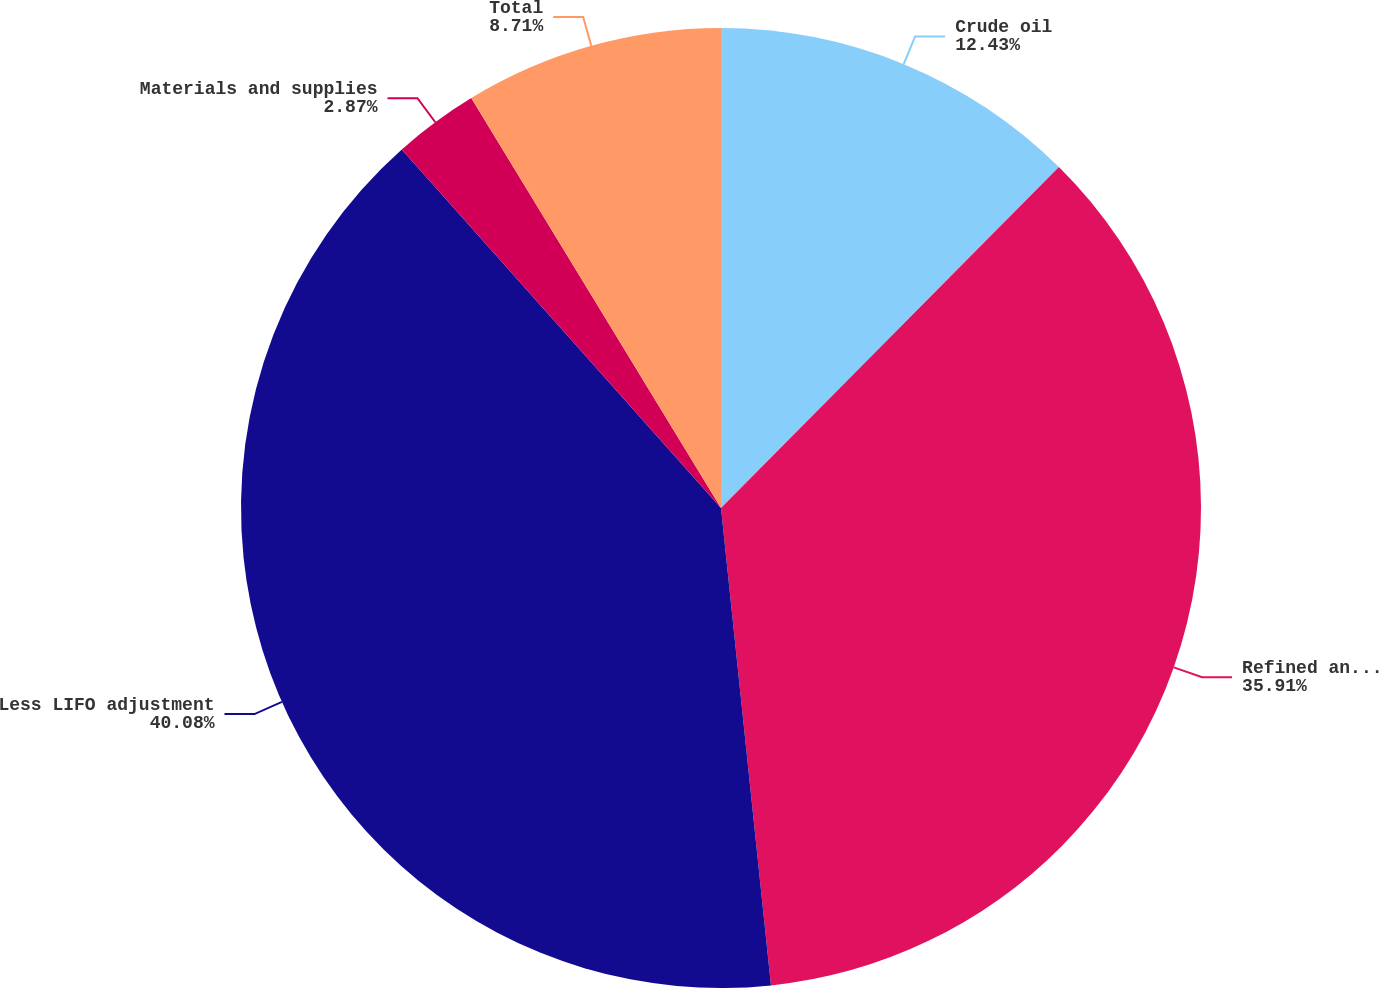Convert chart. <chart><loc_0><loc_0><loc_500><loc_500><pie_chart><fcel>Crude oil<fcel>Refined and other finished<fcel>Less LIFO adjustment<fcel>Materials and supplies<fcel>Total<nl><fcel>12.43%<fcel>35.91%<fcel>40.08%<fcel>2.87%<fcel>8.71%<nl></chart> 